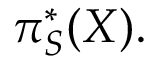Convert formula to latex. <formula><loc_0><loc_0><loc_500><loc_500>\pi _ { S } ^ { * } ( X ) .</formula> 